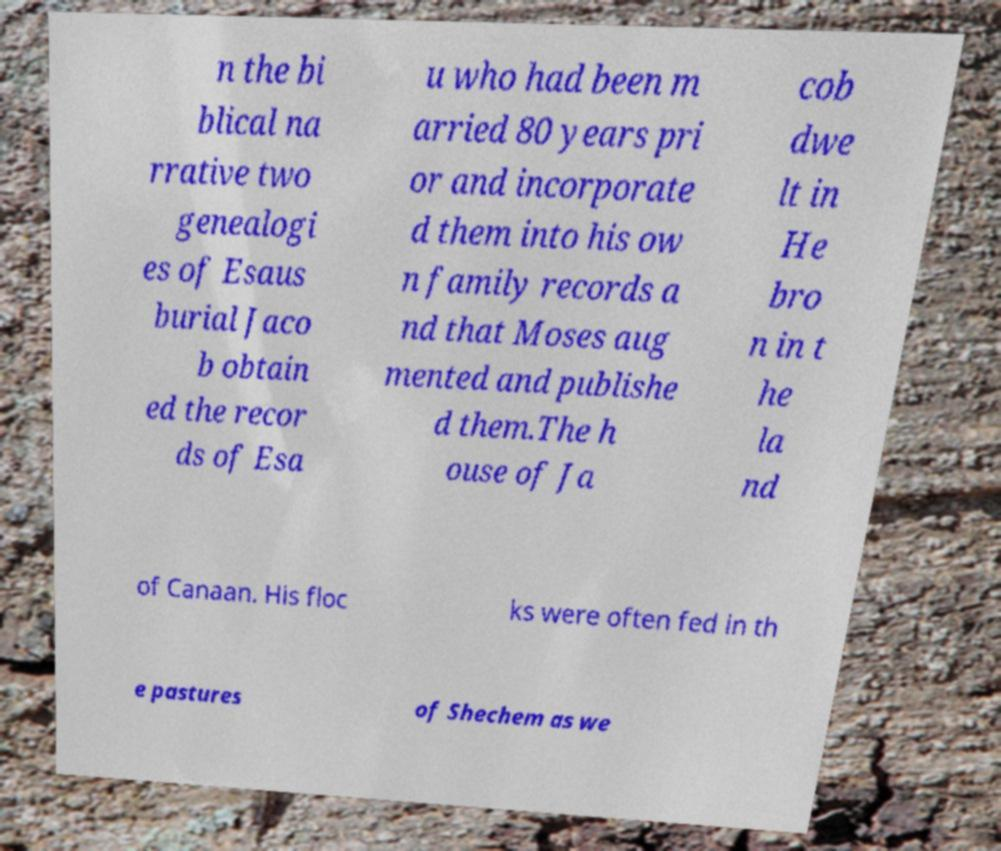Can you read and provide the text displayed in the image?This photo seems to have some interesting text. Can you extract and type it out for me? n the bi blical na rrative two genealogi es of Esaus burial Jaco b obtain ed the recor ds of Esa u who had been m arried 80 years pri or and incorporate d them into his ow n family records a nd that Moses aug mented and publishe d them.The h ouse of Ja cob dwe lt in He bro n in t he la nd of Canaan. His floc ks were often fed in th e pastures of Shechem as we 